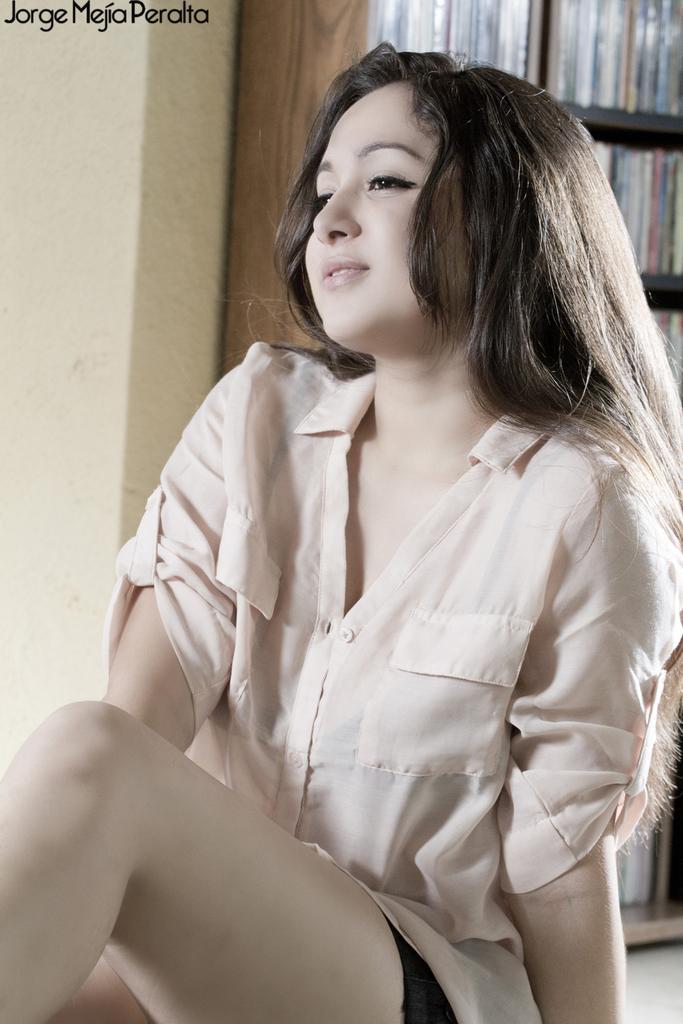Can you describe this image briefly? In the picture we can see a young girl sitting on the floor wearing a white shirt and looking towards the side and in the background, we can see a wall and beside it we can see a rack with full of books in it. 